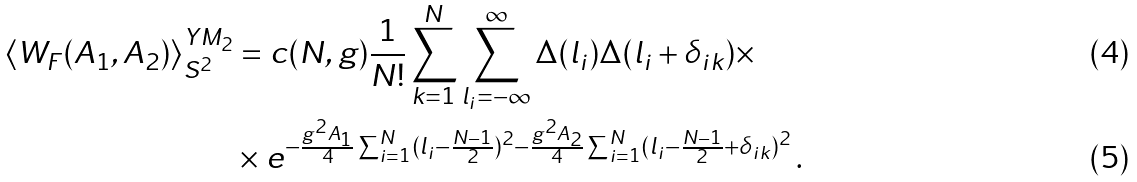<formula> <loc_0><loc_0><loc_500><loc_500>\langle W _ { F } ( A _ { 1 } , A _ { 2 } ) \rangle ^ { Y M _ { 2 } } _ { S ^ { 2 } } & = c ( N , g ) \frac { 1 } { N ! } \sum _ { k = 1 } ^ { N } \sum _ { l _ { i } = - \infty } ^ { \infty } \Delta ( l _ { i } ) \Delta ( l _ { i } + \delta _ { i k } ) \times \\ & \times e ^ { - \frac { g ^ { 2 } A _ { 1 } } { 4 } \sum _ { i = 1 } ^ { N } ( l _ { i } - \frac { N - 1 } { 2 } ) ^ { 2 } - \frac { g ^ { 2 } A _ { 2 } } { 4 } \sum _ { i = 1 } ^ { N } ( l _ { i } - \frac { N - 1 } { 2 } + \delta _ { i k } ) ^ { 2 } } \, .</formula> 